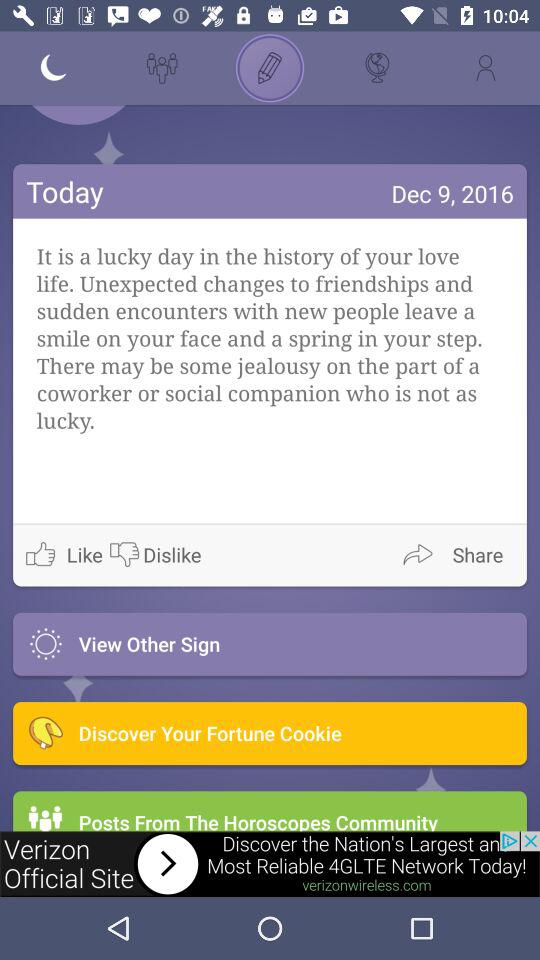What date is shown on the screen? The date shown on the screen is December 9, 2016. 